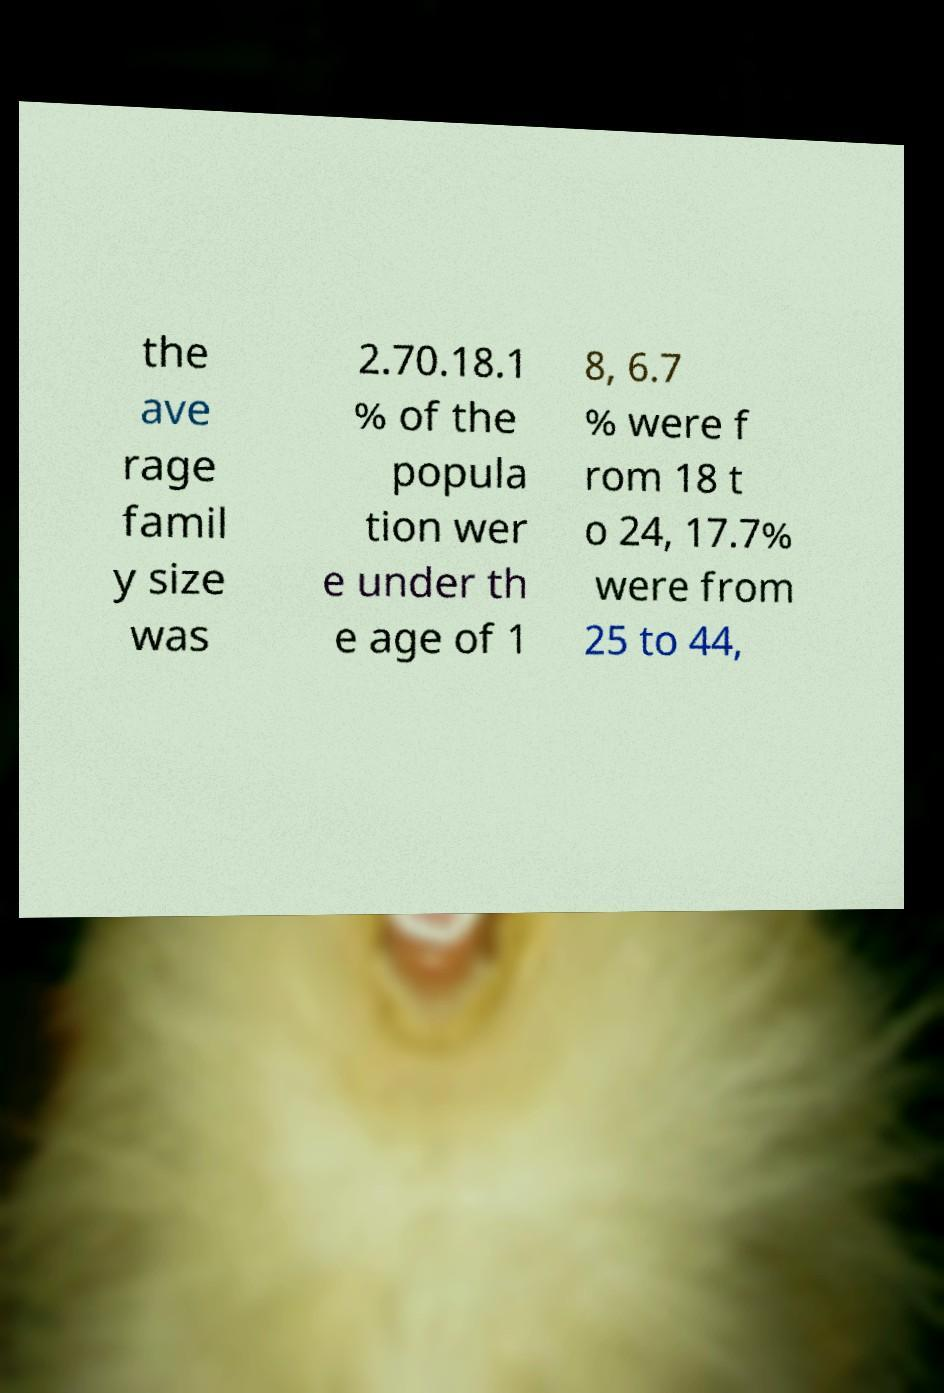For documentation purposes, I need the text within this image transcribed. Could you provide that? the ave rage famil y size was 2.70.18.1 % of the popula tion wer e under th e age of 1 8, 6.7 % were f rom 18 t o 24, 17.7% were from 25 to 44, 